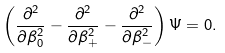Convert formula to latex. <formula><loc_0><loc_0><loc_500><loc_500>\left ( \frac { \partial ^ { 2 } } { \partial \beta _ { 0 } ^ { 2 } } - \frac { \partial ^ { 2 } } { \partial \beta _ { + } ^ { 2 } } - \frac { \partial ^ { 2 } } { \partial \beta _ { - } ^ { 2 } } \right ) \Psi = 0 .</formula> 